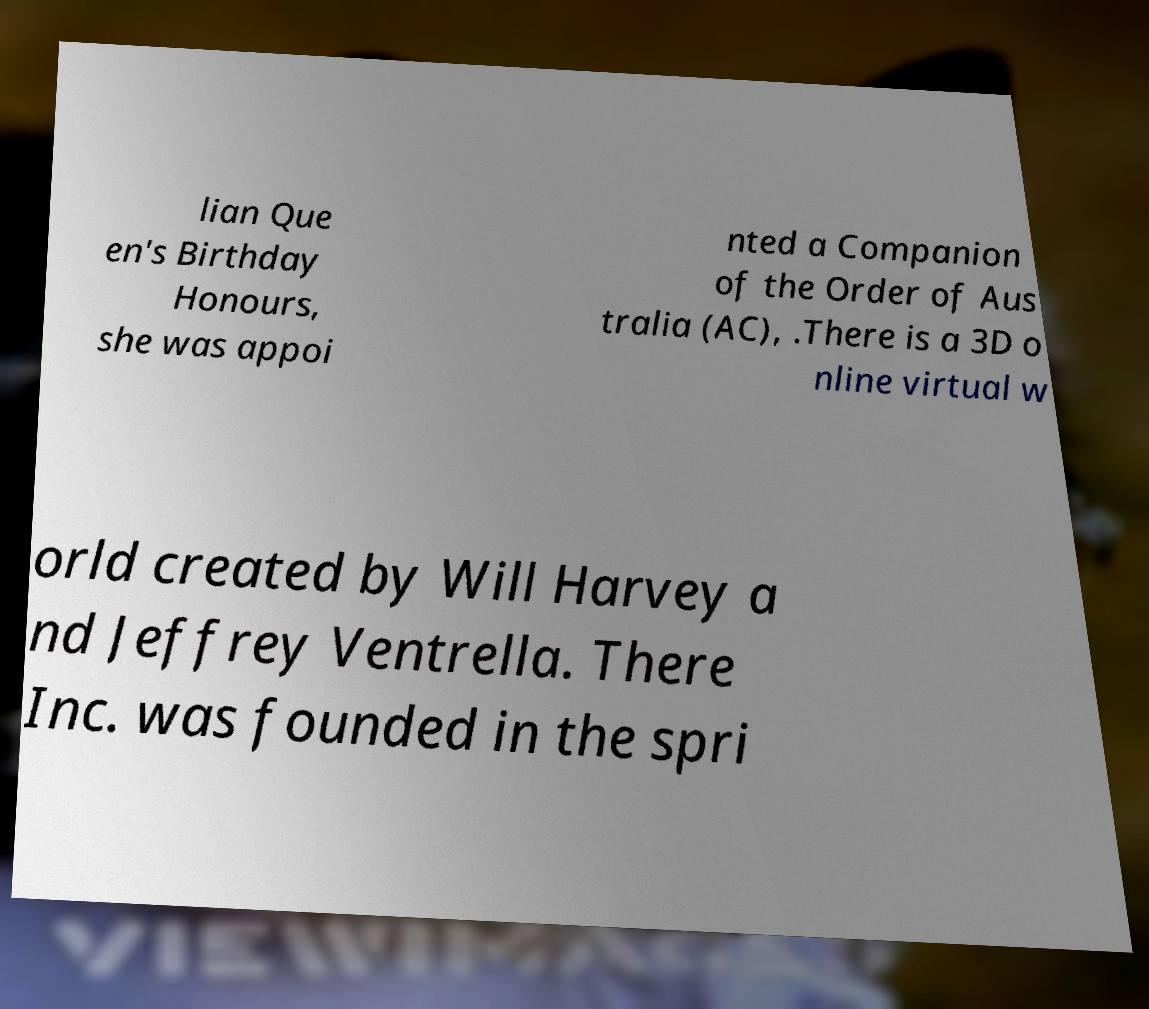Please identify and transcribe the text found in this image. lian Que en's Birthday Honours, she was appoi nted a Companion of the Order of Aus tralia (AC), .There is a 3D o nline virtual w orld created by Will Harvey a nd Jeffrey Ventrella. There Inc. was founded in the spri 